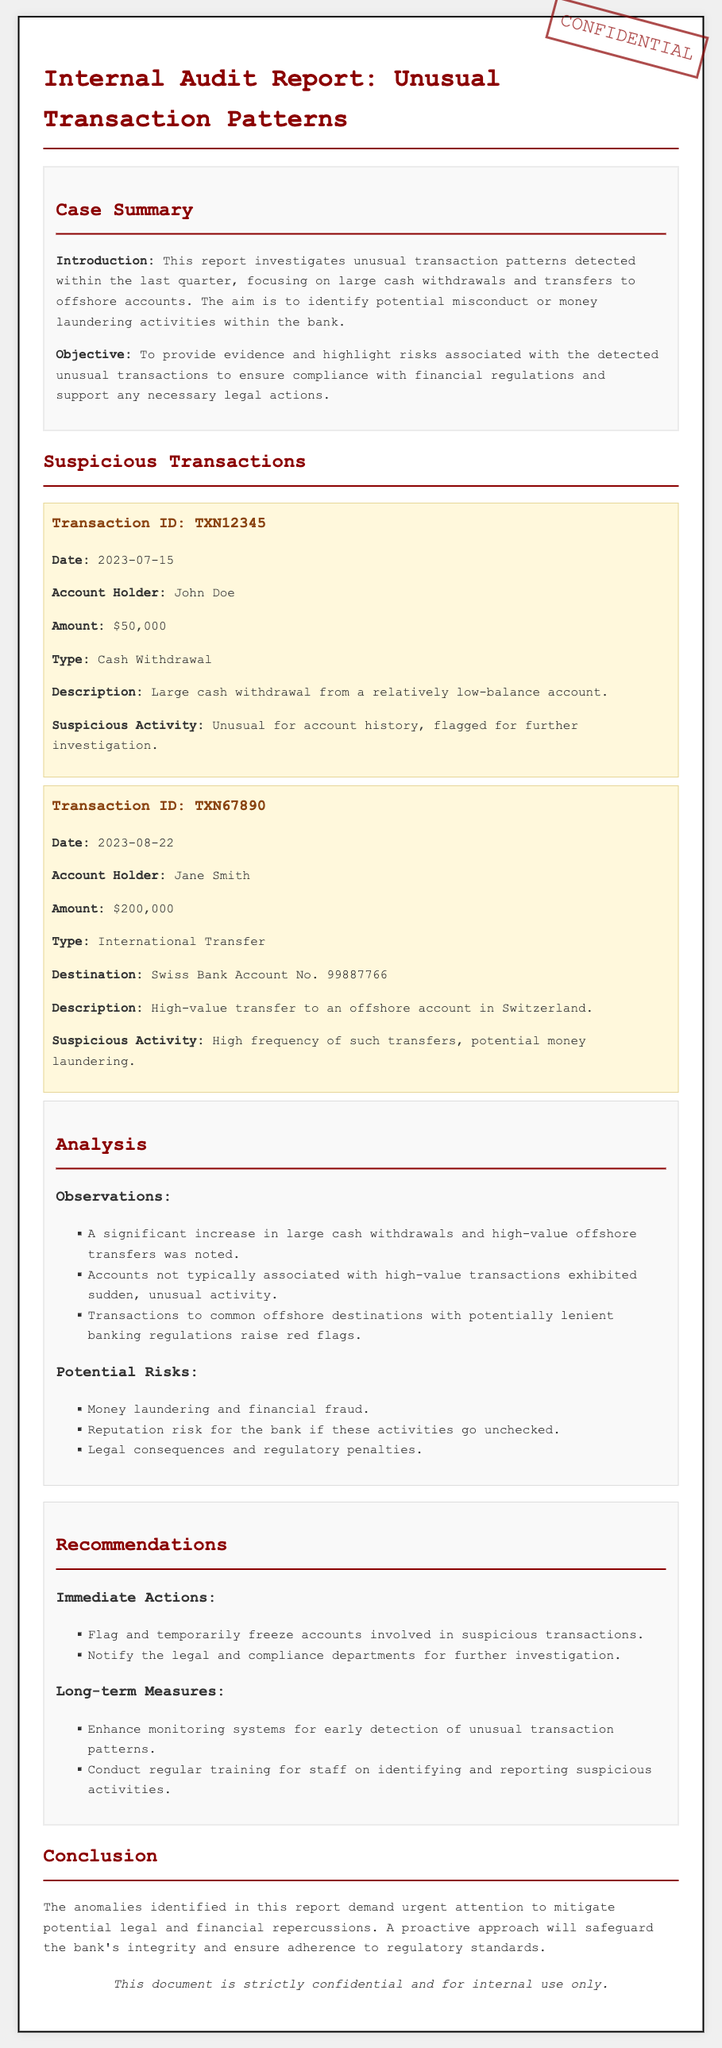What is the date of Transaction ID TXN12345? The document provides the date of this transaction, which is 2023-07-15.
Answer: 2023-07-15 Who is the account holder for Transaction ID TXN67890? The document states that Jane Smith is the account holder for this transaction.
Answer: Jane Smith What is the amount of large cash withdrawal flagged for investigation? The report identifies a large cash withdrawal amounting to $50,000.
Answer: $50,000 What is one potential risk highlighted in the analysis section? The document lists money laundering as one of the potential risks associated with the unusual transactions.
Answer: Money laundering What is the main objective of this internal audit report? The report's objective is to provide evidence and highlight risks associated with the detected unusual transactions.
Answer: To provide evidence and highlight risks What kind of transactions showed significant difficulty in the report? The report indicates that large cash withdrawals and high-value offshore transfers showed significant difficulty.
Answer: Large cash withdrawals and high-value offshore transfers What immediate action is recommended in the report? The report recommends flagging and temporarily freezing accounts involved in suspicious transactions as an immediate action.
Answer: Flag and temporarily freeze accounts To which country was the high-value transfer (Transaction ID TXN67890) directed? The document specifies that the high-value transfer was directed to a Swiss bank account.
Answer: Switzerland 